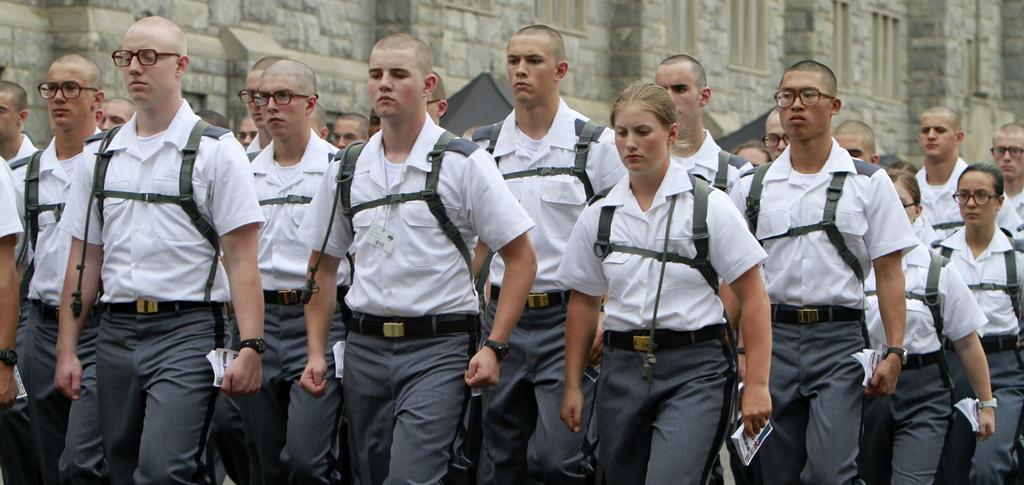Can you describe this image briefly? In this image we can see there are group of people standing on the ground, they are wearing white shirts and holding books in the hand, at the back there is a wall. 